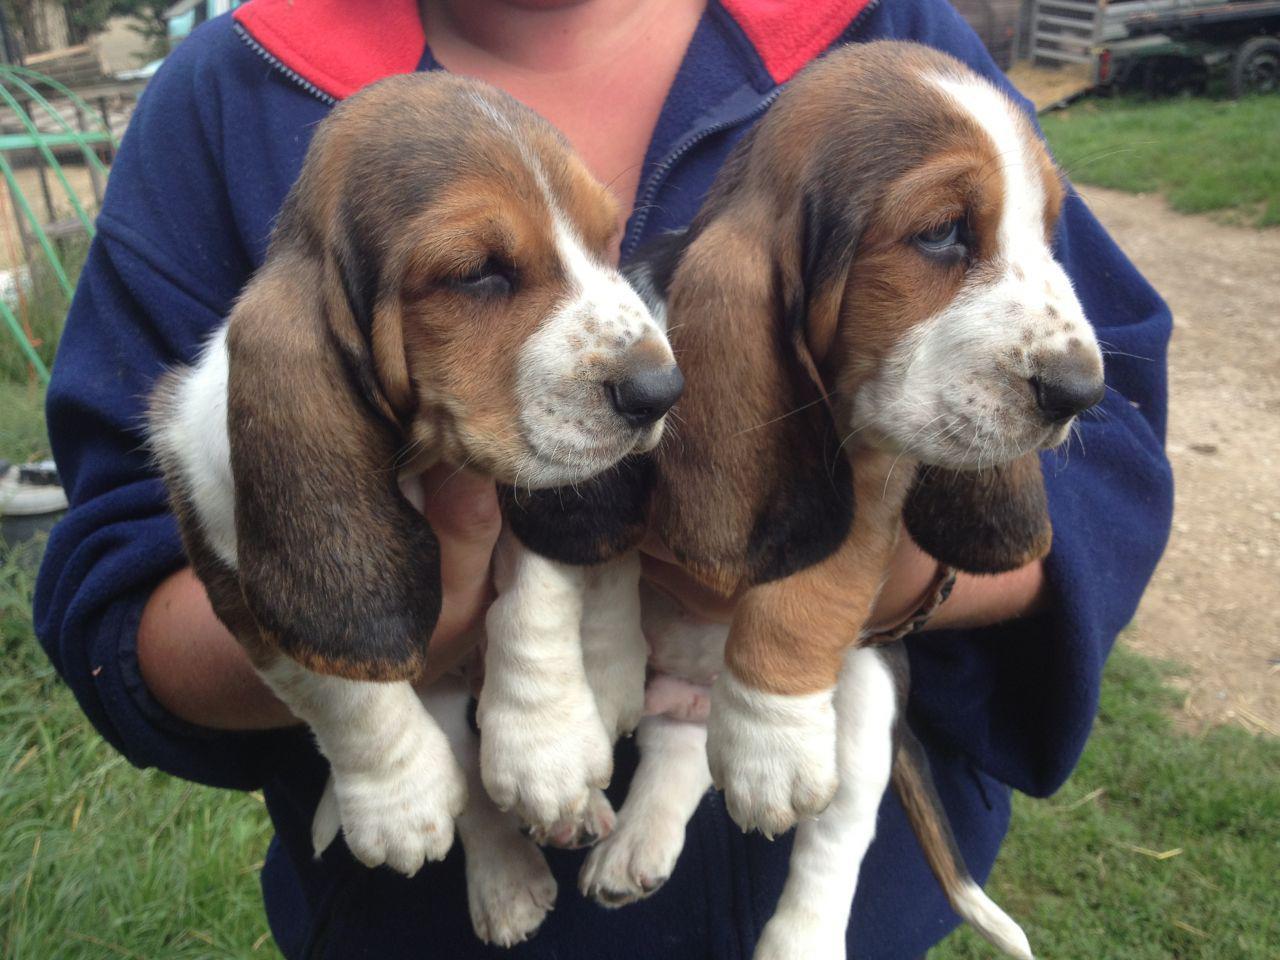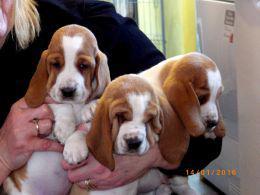The first image is the image on the left, the second image is the image on the right. Assess this claim about the two images: "There are no less than five dogs". Correct or not? Answer yes or no. Yes. The first image is the image on the left, the second image is the image on the right. Examine the images to the left and right. Is the description "Right image shows exactly three basset hounds." accurate? Answer yes or no. Yes. 